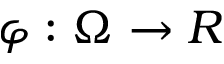Convert formula to latex. <formula><loc_0><loc_0><loc_500><loc_500>\varphi \colon \Omega \to R</formula> 